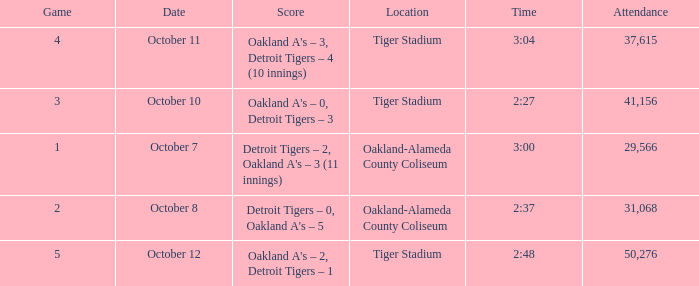What is the number of people in attendance when the time is 3:00? 29566.0. Can you parse all the data within this table? {'header': ['Game', 'Date', 'Score', 'Location', 'Time', 'Attendance'], 'rows': [['4', 'October 11', "Oakland A's – 3, Detroit Tigers – 4 (10 innings)", 'Tiger Stadium', '3:04', '37,615'], ['3', 'October 10', "Oakland A's – 0, Detroit Tigers – 3", 'Tiger Stadium', '2:27', '41,156'], ['1', 'October 7', "Detroit Tigers – 2, Oakland A's – 3 (11 innings)", 'Oakland-Alameda County Coliseum', '3:00', '29,566'], ['2', 'October 8', "Detroit Tigers – 0, Oakland A's – 5", 'Oakland-Alameda County Coliseum', '2:37', '31,068'], ['5', 'October 12', "Oakland A's – 2, Detroit Tigers – 1", 'Tiger Stadium', '2:48', '50,276']]} 